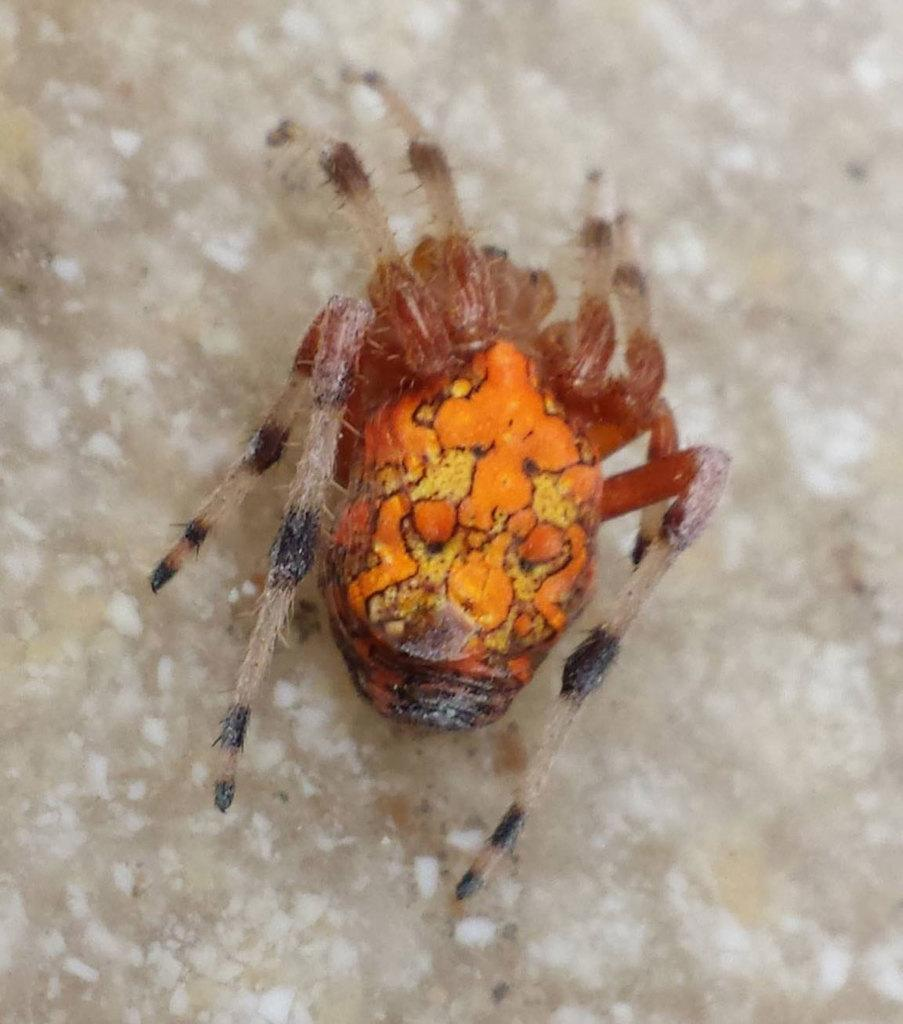What type of creature can be seen in the image? There is an insect in the image. Where is the insect located in the image? The insect is on an object. What type of plant is growing in the crib in the image? There is no crib or plant present in the image; it features an insect on an object. 